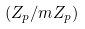<formula> <loc_0><loc_0><loc_500><loc_500>( Z _ { p } / m Z _ { p } )</formula> 